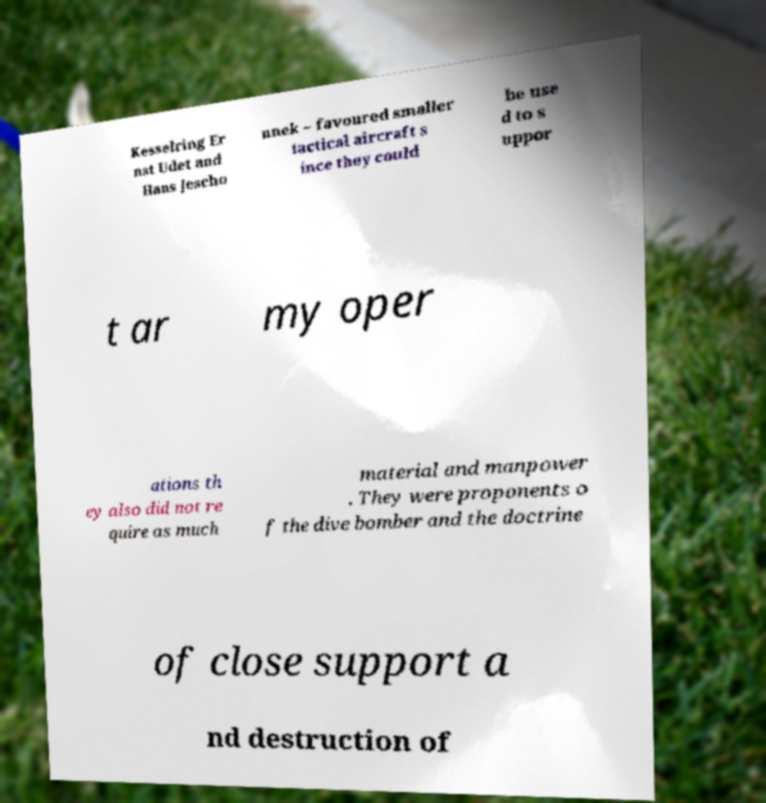Could you assist in decoding the text presented in this image and type it out clearly? Kesselring Er nst Udet and Hans Jescho nnek – favoured smaller tactical aircraft s ince they could be use d to s uppor t ar my oper ations th ey also did not re quire as much material and manpower . They were proponents o f the dive bomber and the doctrine of close support a nd destruction of 